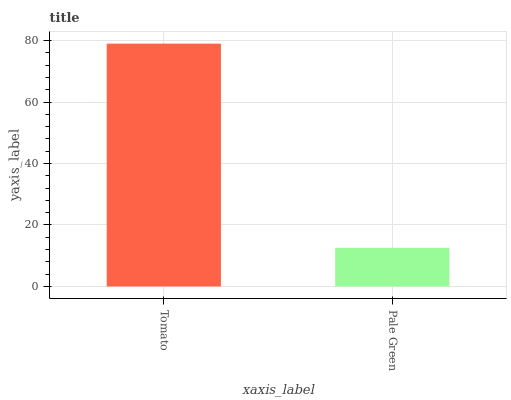Is Pale Green the maximum?
Answer yes or no. No. Is Tomato greater than Pale Green?
Answer yes or no. Yes. Is Pale Green less than Tomato?
Answer yes or no. Yes. Is Pale Green greater than Tomato?
Answer yes or no. No. Is Tomato less than Pale Green?
Answer yes or no. No. Is Tomato the high median?
Answer yes or no. Yes. Is Pale Green the low median?
Answer yes or no. Yes. Is Pale Green the high median?
Answer yes or no. No. Is Tomato the low median?
Answer yes or no. No. 